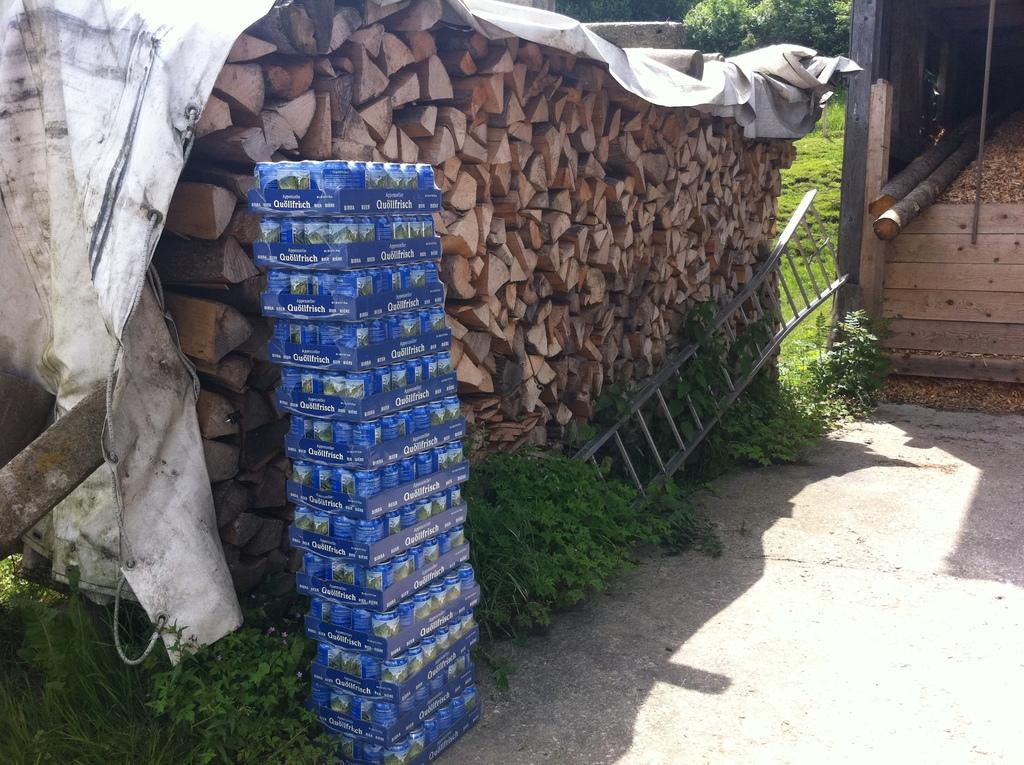What type of material is used for the objects in the image? The objects in the image are made of wood. What is the tall, vertical structure in the image? There is a ladder in the image. What type of vegetation is present in the image? There are plants and grass in the image. Can you describe any other objects in the image besides the wooden ones, ladder, plants, and grass? There are some other unspecified objects in the image. How many seeds are planted in the yam in the image? There is no yam or seeds present in the image. 